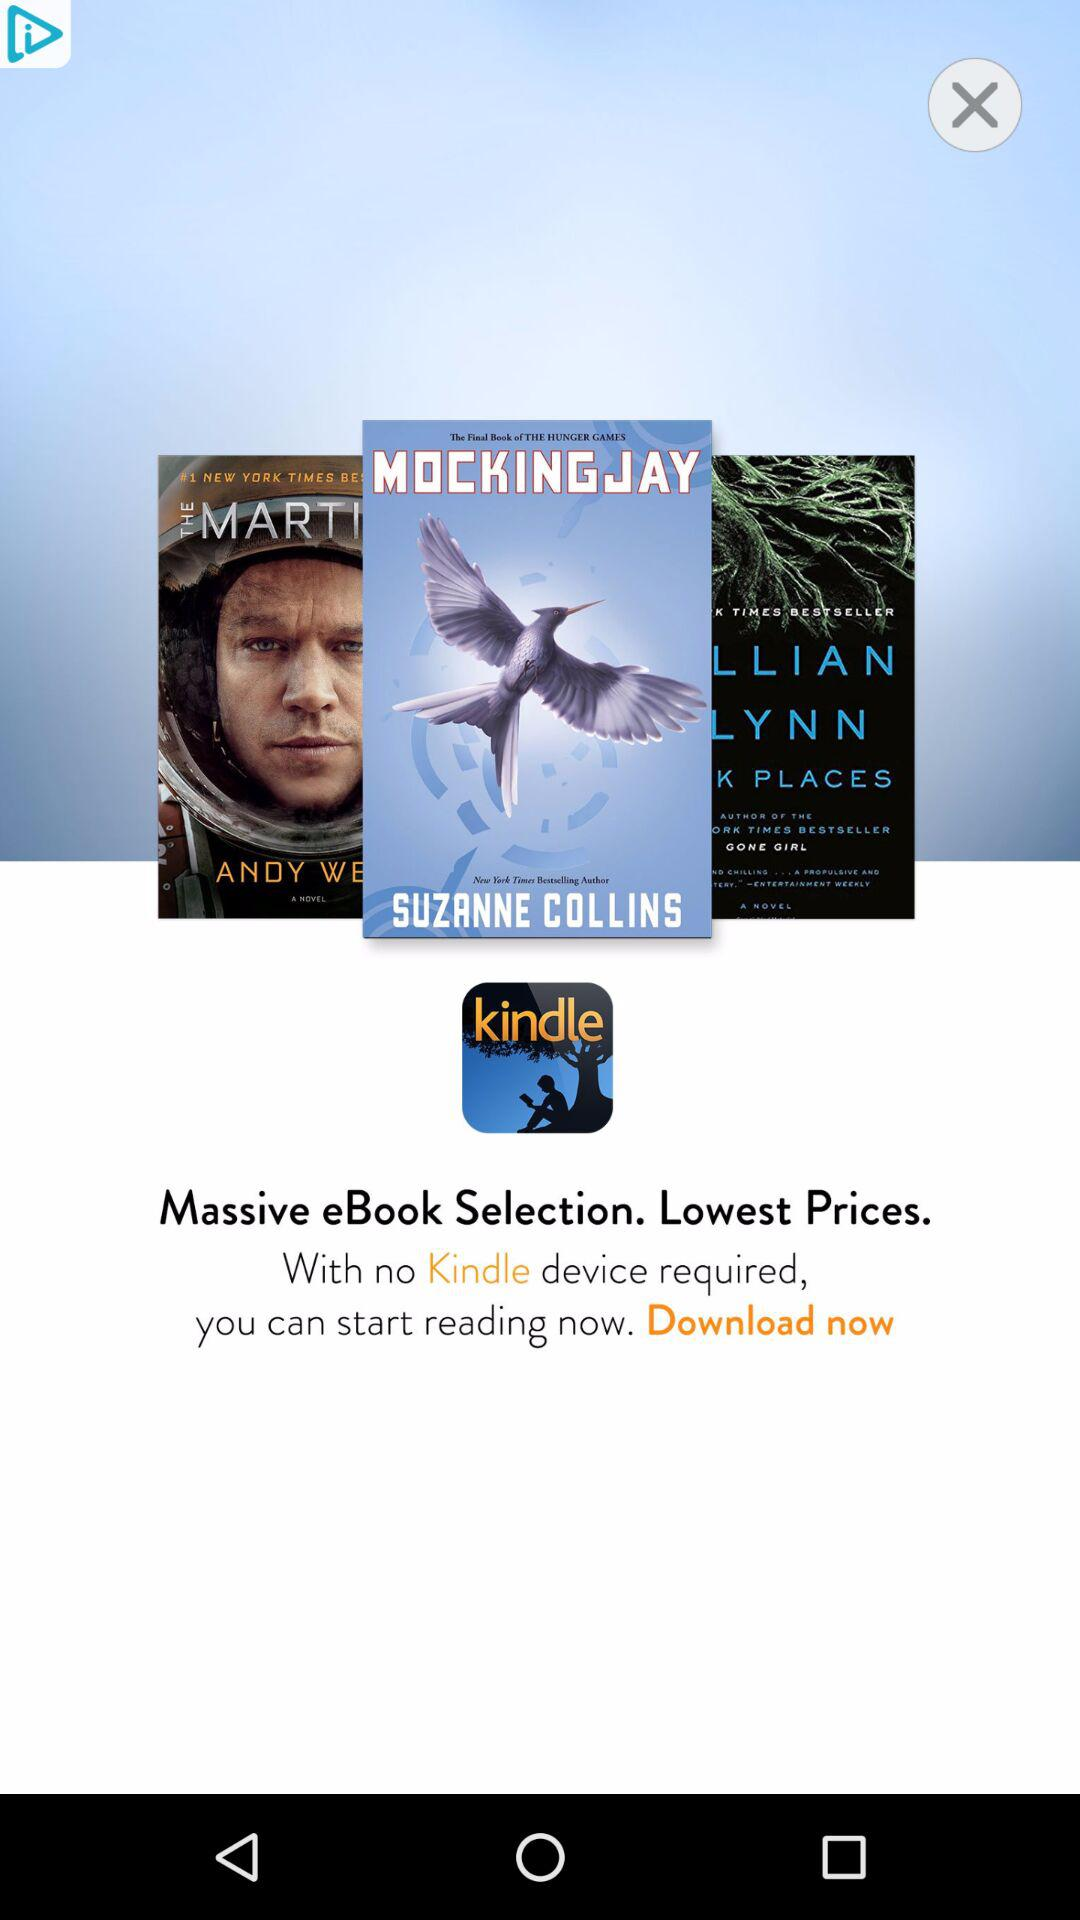How many book covers are there?
Answer the question using a single word or phrase. 3 